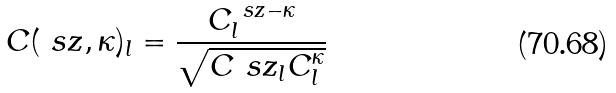Convert formula to latex. <formula><loc_0><loc_0><loc_500><loc_500>C ( \ s z , \kappa ) _ { l } = \frac { C ^ { \ s z - \kappa } _ { l } } { \sqrt { C ^ { \ } s z _ { l } C ^ { \kappa } _ { l } } }</formula> 